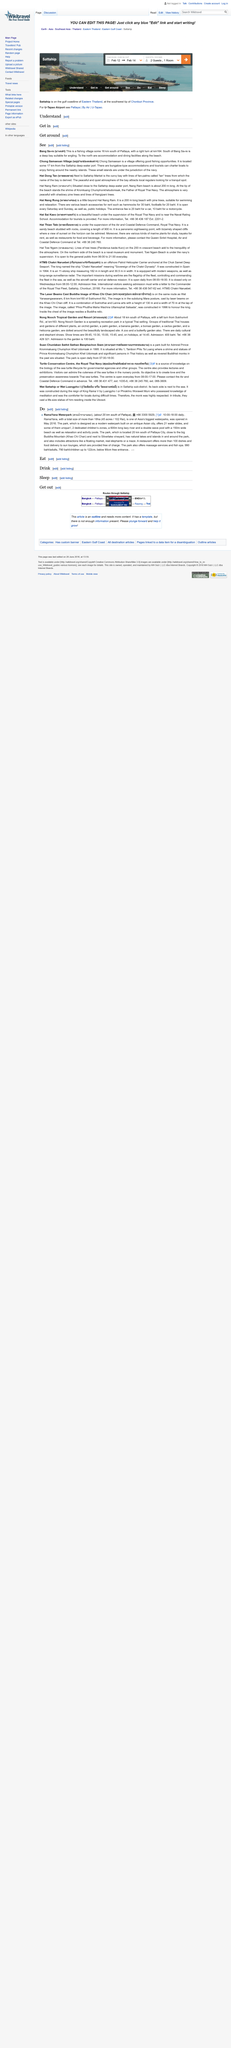Indicate a few pertinent items in this graphic. Bang Sa-re is a village located 16 kilometers south of Pattaya, Thailand. The Chong Samaesan Village is located 17 km from the Sattahip deep-water port. Chong Samaesan Village is a village where tourists can charter boats to explore the area. 